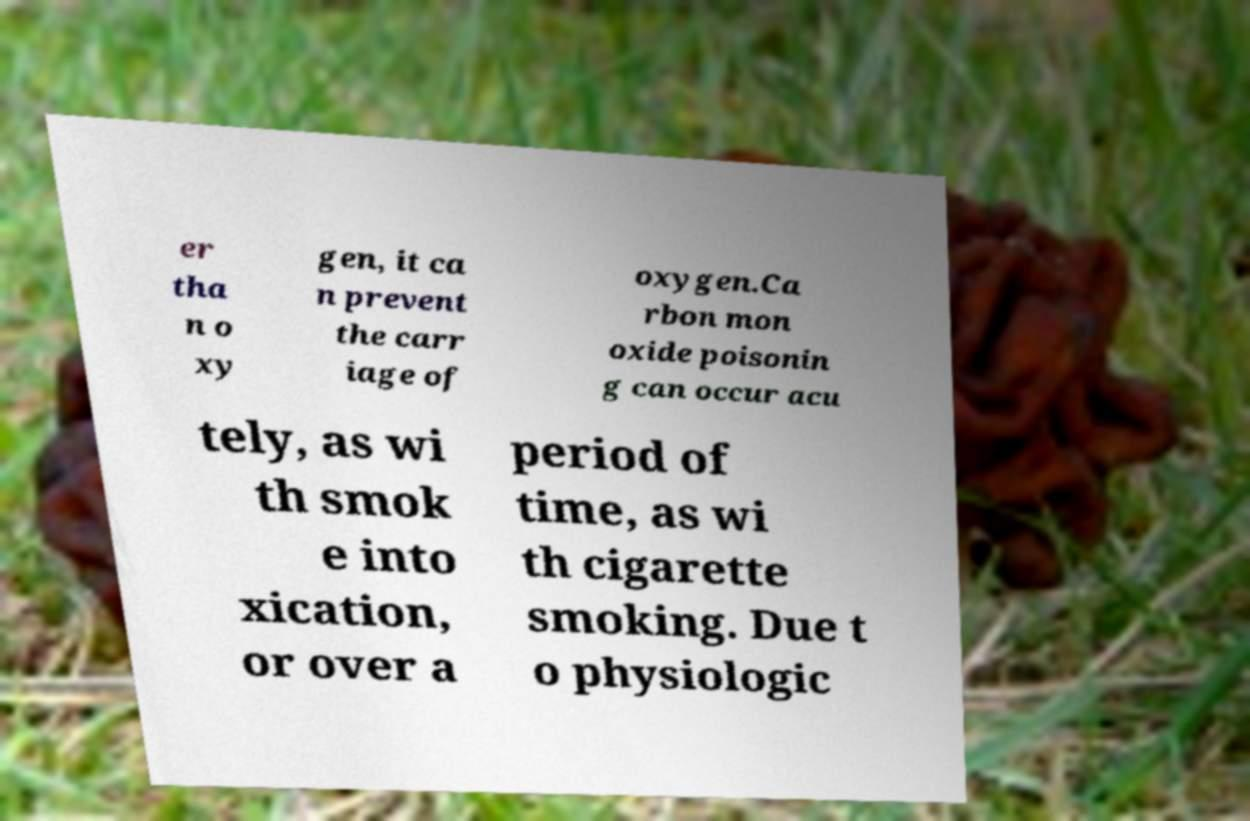Could you extract and type out the text from this image? er tha n o xy gen, it ca n prevent the carr iage of oxygen.Ca rbon mon oxide poisonin g can occur acu tely, as wi th smok e into xication, or over a period of time, as wi th cigarette smoking. Due t o physiologic 